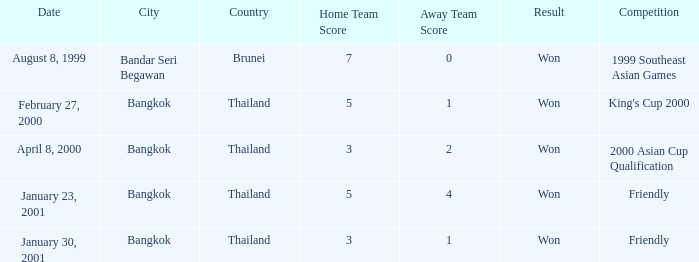On what date was the game that had a score of 7–0? August 8, 1999. 